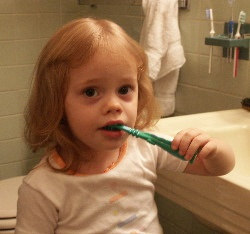Describe the objects in this image and their specific colors. I can see people in olive, maroon, gray, brown, and tan tones, sink in olive and tan tones, toilet in olive, tan, and gray tones, toothbrush in olive, darkgreen, black, and green tones, and toothbrush in olive and tan tones in this image. 